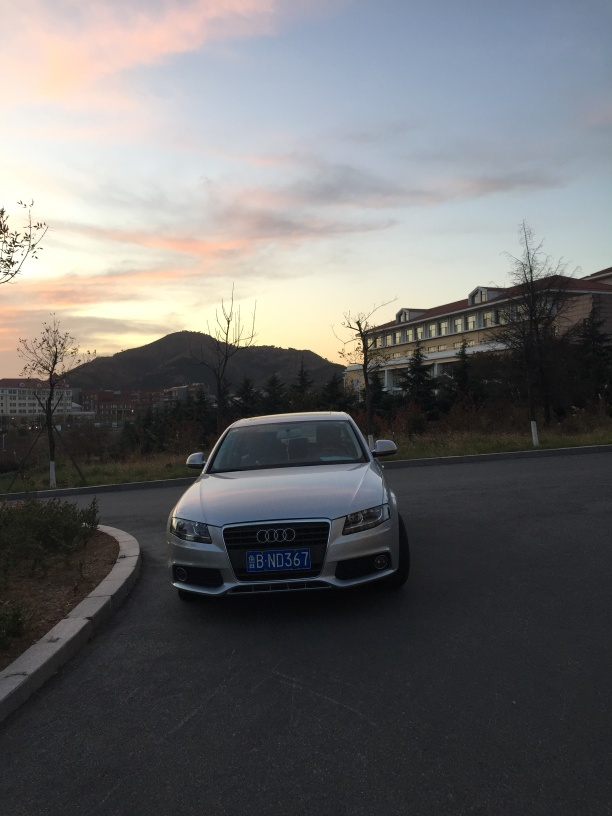What suggestions would you give to improve this photograph? To improve this photograph, one could wait for a moment when the car is positioned in a designated parking space to avoid creating a feeling of disorder. Additionally, playing with camera settings such as ISO, aperture, and shutter speed might bring more sharpness to the image. Capturing the photograph from a lower angle could also add dynamism and emphasize the car and sunset. 